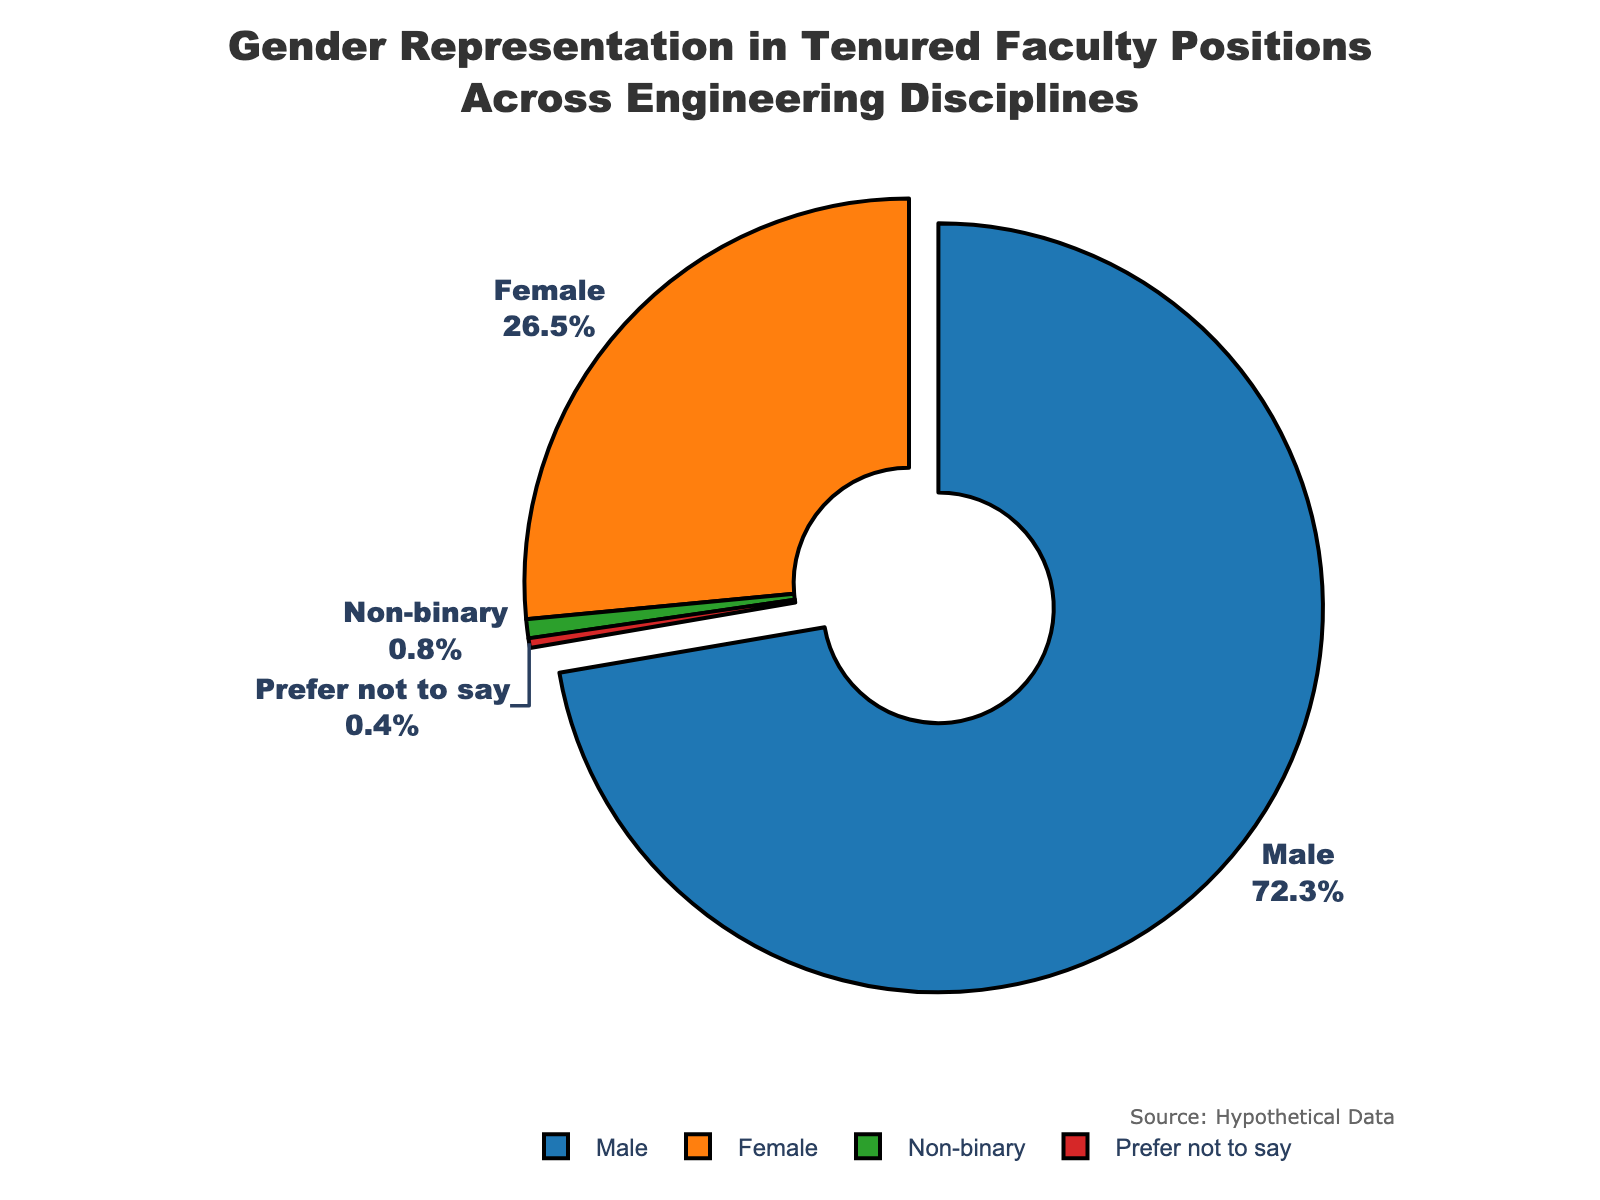What percentage of the tenured faculty identify as non-binary or prefer not to say? To find the combined percentage, add the percentages for 'Non-binary' and 'Prefer not to say': 0.8% + 0.4% = 1.2%
Answer: 1.2% Which gender has the highest proportion in tenured faculty positions? Visual inspection shows that 'Male' occupies the largest portion of the pie chart with 72.3%
Answer: Male How much greater is the percentage of males than females in the dataset? Subtract the percentage of 'Female' from 'Male': 72.3% - 26.5% = 45.8%
Answer: 45.8% What is the sum of percentages for all the genders represented in the figure? Add all percentages: 72.3% (Male) + 26.5% (Female) + 0.8% (Non-binary) + 0.4% (Prefer not to say) = 100%
Answer: 100% Which category has the smallest representation? The slice labeled 'Prefer not to say' is the smallest with 0.4%
Answer: Prefer not to say Describe the visual attributes of the pie chart that highlight the 'Male' category. The 'Male' category is represented by the largest slice of the pie chart, pulled outward slightly for emphasis, and colored in a distinct blue
Answer: Large blue slice, pulled outward What is the difference in percentage points between 'Female' and 'Non-binary' categories? Subtract the percentage of 'Non-binary' from 'Female': 26.5% - 0.8% = 25.7%
Answer: 25.7% Among the categories 'Female' and 'Non-binary', which one has a higher percentage and by how much? 'Female' has a higher percentage. Subtract the percentage of 'Non-binary' from 'Female': 26.5% - 0.8% = 25.7%
Answer: Female, 25.7% What percentage of faculty chose 'Prefer not to say' in the survey? The slice labeled 'Prefer not to say' in the pie chart shows 0.4%
Answer: 0.4% 